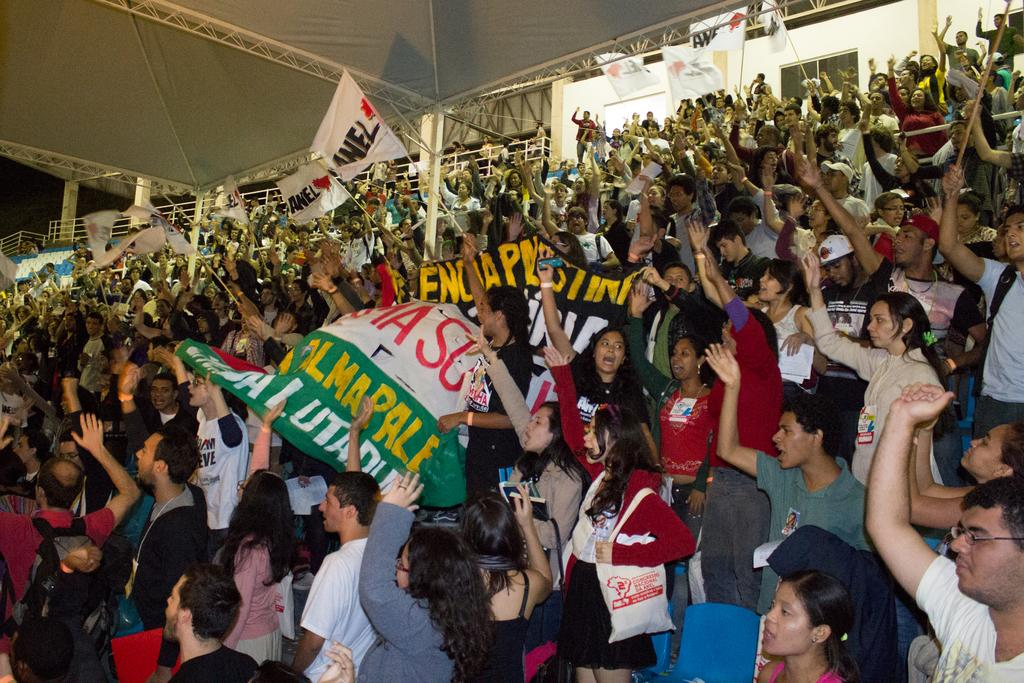How many people are in the image? There are many people in the image. Where are the people located in the image? The people are standing in a stadium. What are the people holding in the image? The people are holding banners and flags. What can be seen in the background of the image? There is a wall in the background of the image. What type of account does the son have with the bank in the image? There is no son or bank mentioned in the image; it features people in a stadium holding banners and flags. 